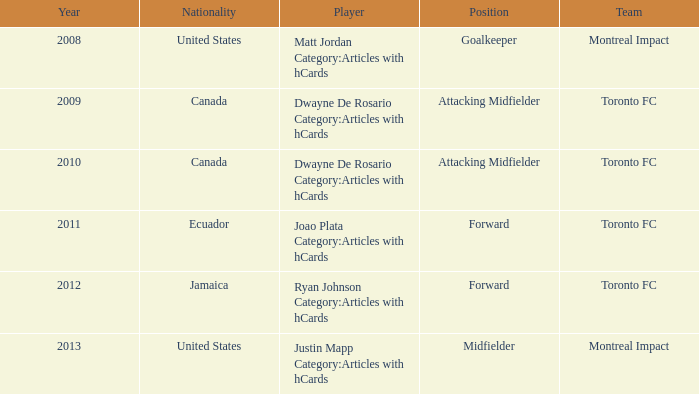After 2009, what's the nationality of a player named Dwayne de Rosario Category:articles with hcards? Canada. Help me parse the entirety of this table. {'header': ['Year', 'Nationality', 'Player', 'Position', 'Team'], 'rows': [['2008', 'United States', 'Matt Jordan Category:Articles with hCards', 'Goalkeeper', 'Montreal Impact'], ['2009', 'Canada', 'Dwayne De Rosario Category:Articles with hCards', 'Attacking Midfielder', 'Toronto FC'], ['2010', 'Canada', 'Dwayne De Rosario Category:Articles with hCards', 'Attacking Midfielder', 'Toronto FC'], ['2011', 'Ecuador', 'Joao Plata Category:Articles with hCards', 'Forward', 'Toronto FC'], ['2012', 'Jamaica', 'Ryan Johnson Category:Articles with hCards', 'Forward', 'Toronto FC'], ['2013', 'United States', 'Justin Mapp Category:Articles with hCards', 'Midfielder', 'Montreal Impact']]} 